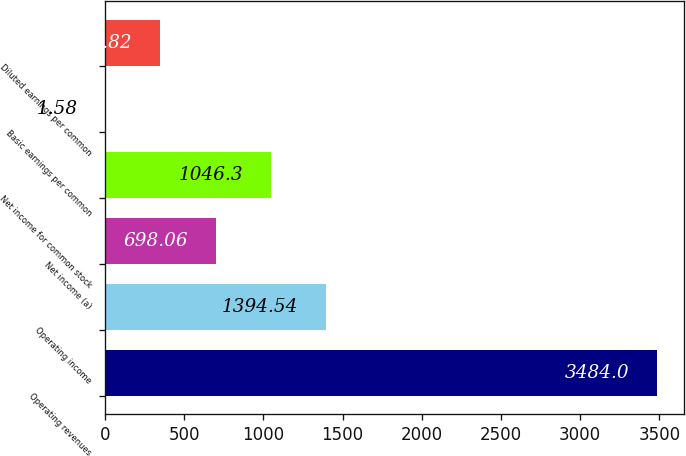Convert chart to OTSL. <chart><loc_0><loc_0><loc_500><loc_500><bar_chart><fcel>Operating revenues<fcel>Operating income<fcel>Net income (a)<fcel>Net income for common stock<fcel>Basic earnings per common<fcel>Diluted earnings per common<nl><fcel>3484<fcel>1394.54<fcel>698.06<fcel>1046.3<fcel>1.58<fcel>349.82<nl></chart> 